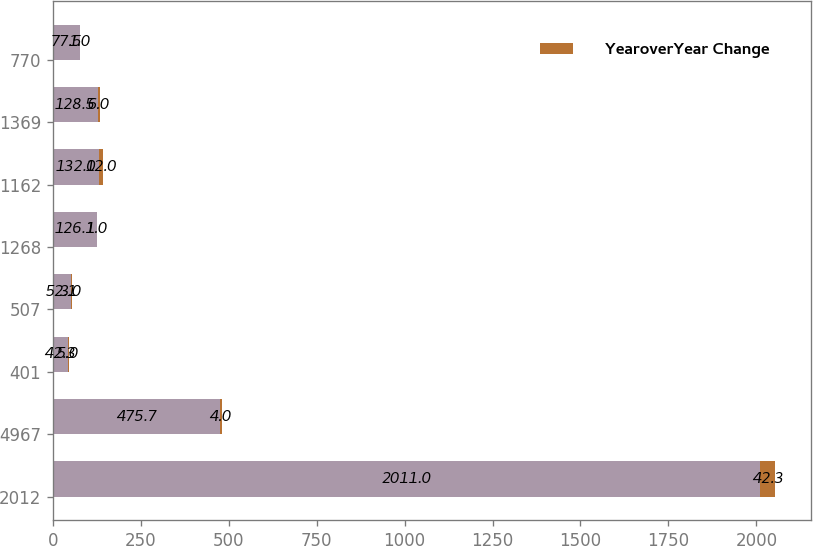Convert chart to OTSL. <chart><loc_0><loc_0><loc_500><loc_500><stacked_bar_chart><ecel><fcel>2012<fcel>4967<fcel>401<fcel>507<fcel>1268<fcel>1162<fcel>1369<fcel>770<nl><fcel>nan<fcel>2011<fcel>475.7<fcel>42.3<fcel>52.1<fcel>126.1<fcel>132<fcel>128.5<fcel>77.5<nl><fcel>YearoverYear Change<fcel>42.3<fcel>4<fcel>5<fcel>3<fcel>1<fcel>12<fcel>6<fcel>1<nl></chart> 